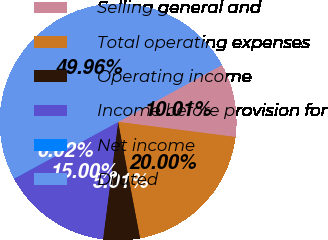Convert chart. <chart><loc_0><loc_0><loc_500><loc_500><pie_chart><fcel>Selling general and<fcel>Total operating expenses<fcel>Operating income<fcel>Income before provision for<fcel>Net income<fcel>Diluted<nl><fcel>10.01%<fcel>20.0%<fcel>5.01%<fcel>15.0%<fcel>0.02%<fcel>49.96%<nl></chart> 